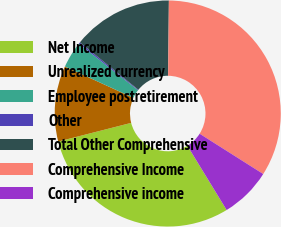<chart> <loc_0><loc_0><loc_500><loc_500><pie_chart><fcel>Net Income<fcel>Unrealized currency<fcel>Employee postretirement<fcel>Other<fcel>Total Other Comprehensive<fcel>Comprehensive Income<fcel>Comprehensive income<nl><fcel>29.74%<fcel>10.81%<fcel>3.77%<fcel>0.24%<fcel>14.33%<fcel>33.83%<fcel>7.29%<nl></chart> 